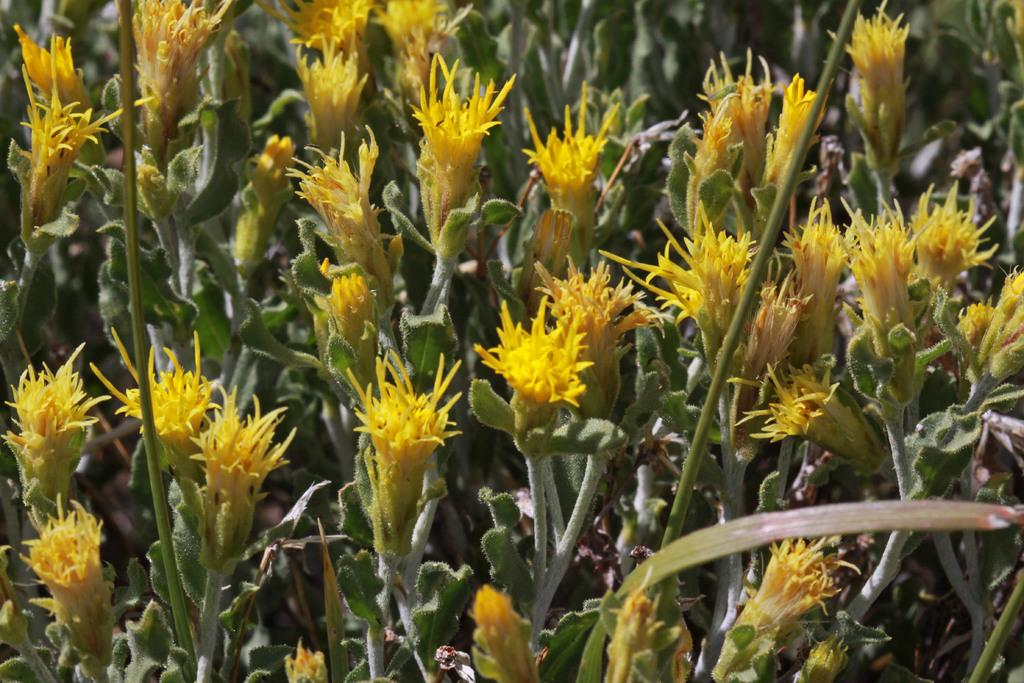What type of flora can be seen in the image? There are flowers and plants in the image. What color are the flowers in the image? The flowers are yellow in color. What color are the plants in the image? The plants are green in color. How many stamps are attached to the dog in the image? There is no dog or stamp present in the image. What is the mass of the flowers in the image? The mass of the flowers cannot be determined from the image alone, as it does not provide any information about their size or weight. 